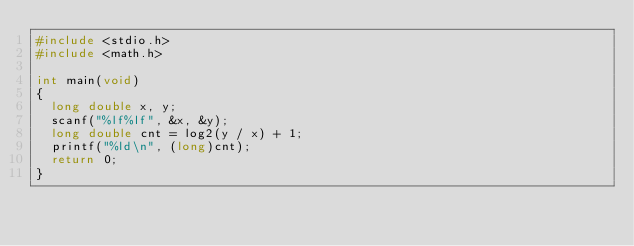Convert code to text. <code><loc_0><loc_0><loc_500><loc_500><_C_>#include <stdio.h>
#include <math.h>

int main(void)
{
	long double x, y;
	scanf("%lf%lf", &x, &y);
	long double cnt = log2(y / x) + 1;
	printf("%ld\n", (long)cnt);
	return 0;
}</code> 